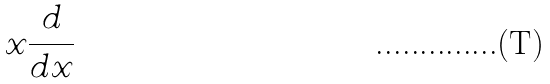<formula> <loc_0><loc_0><loc_500><loc_500>x \frac { d } { d x }</formula> 